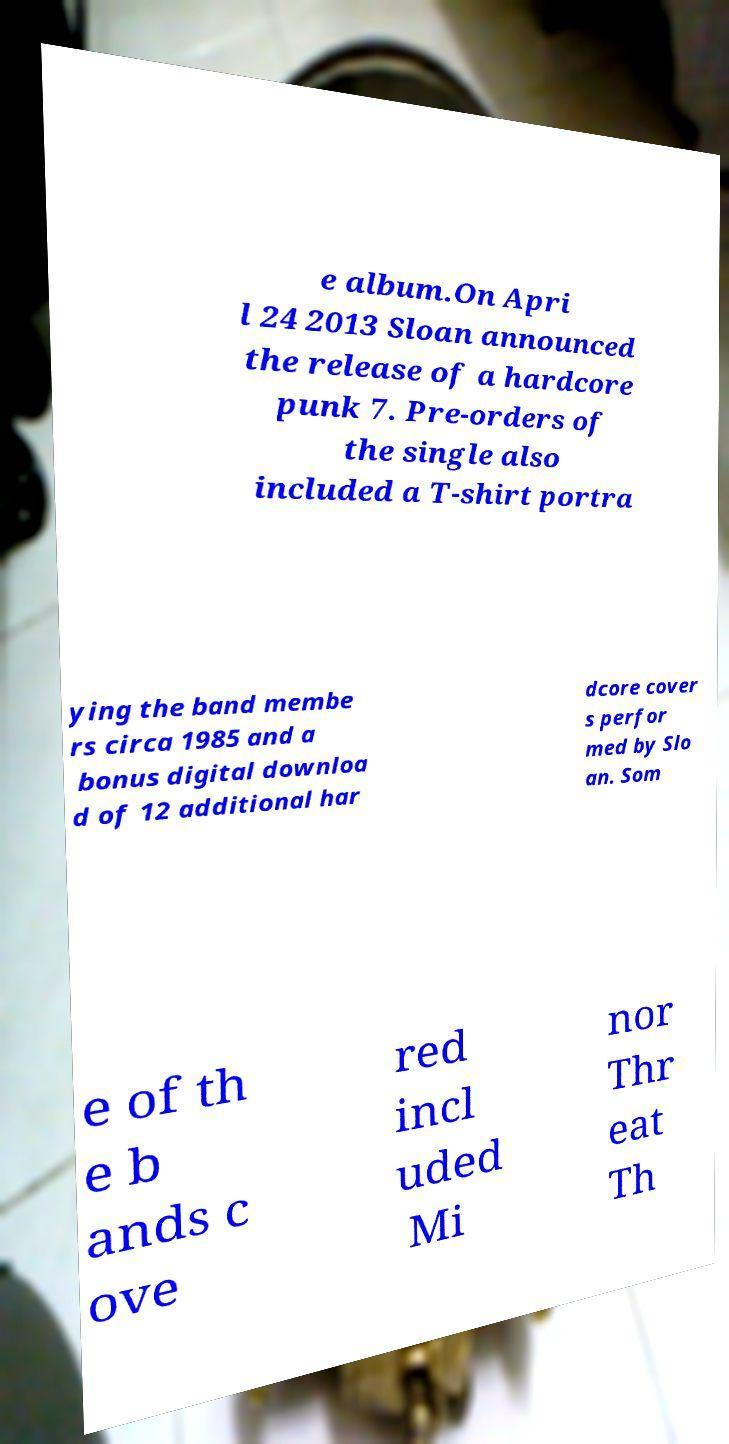Could you assist in decoding the text presented in this image and type it out clearly? e album.On Apri l 24 2013 Sloan announced the release of a hardcore punk 7. Pre-orders of the single also included a T-shirt portra ying the band membe rs circa 1985 and a bonus digital downloa d of 12 additional har dcore cover s perfor med by Slo an. Som e of th e b ands c ove red incl uded Mi nor Thr eat Th 